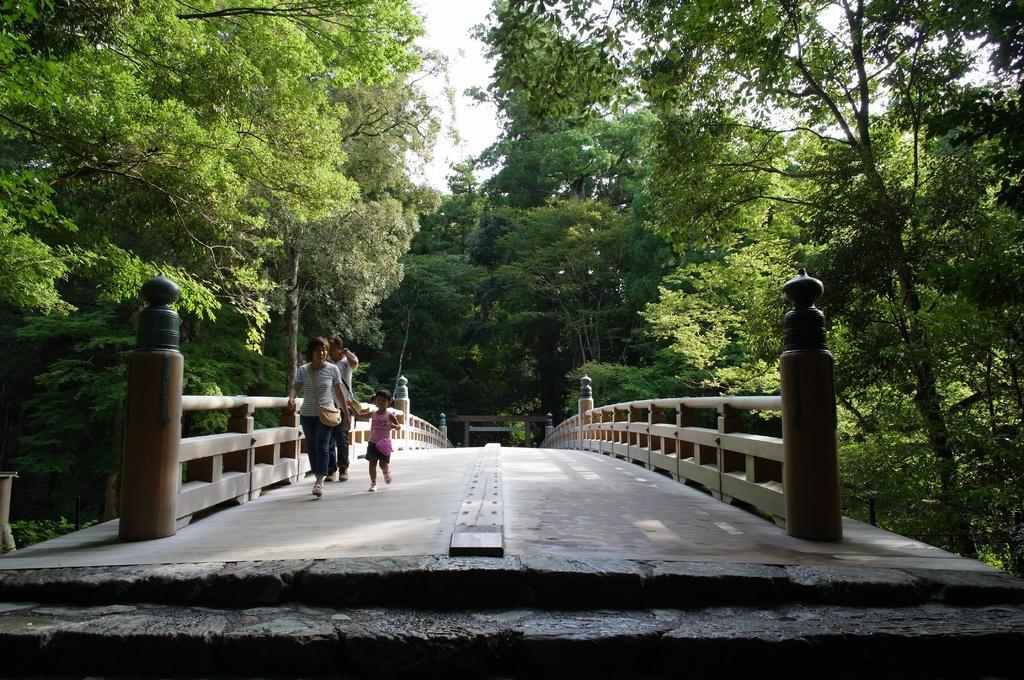In one or two sentences, can you explain what this image depicts? In this image we can see a walkway bridge and three people walking over it. In the background we can see sky and trees. 